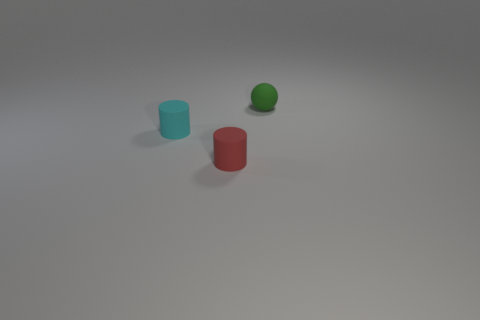Add 2 big cyan metallic cubes. How many objects exist? 5 Subtract all cylinders. How many objects are left? 1 Subtract all matte cylinders. Subtract all green matte objects. How many objects are left? 0 Add 2 tiny cyan cylinders. How many tiny cyan cylinders are left? 3 Add 3 rubber cylinders. How many rubber cylinders exist? 5 Subtract 0 gray blocks. How many objects are left? 3 Subtract all red spheres. Subtract all cyan blocks. How many spheres are left? 1 